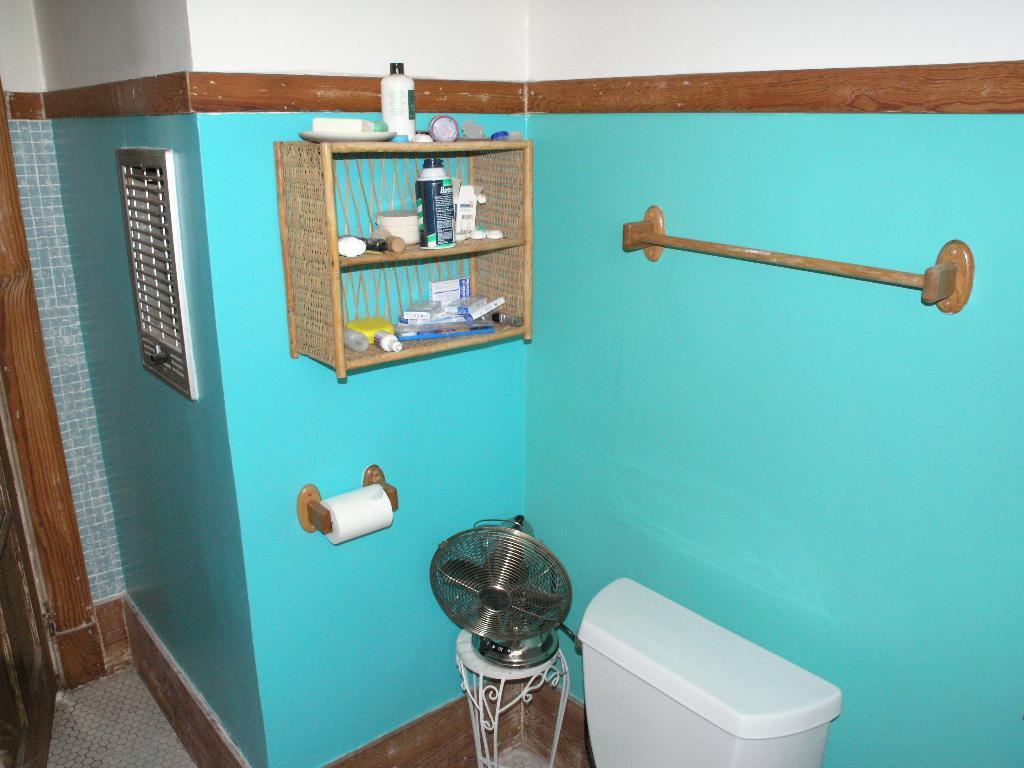In one or two sentences, can you explain what this image depicts? At the bottom there is a flush tank,table fan on a stool,bottle,small boxes,plate and other objects on a stand on the wall and on the left side we can see the door. 